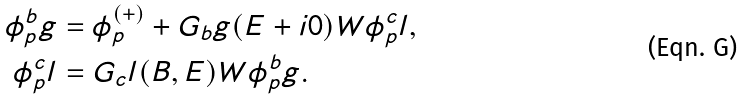<formula> <loc_0><loc_0><loc_500><loc_500>\phi _ { p } ^ { b } g & = \phi _ { p } ^ { ( + ) } + G _ { b } g ( E + i 0 ) W \phi _ { p } ^ { c } l , \\ \phi _ { p } ^ { c } l & = G _ { c } l ( B , E ) W \phi _ { p } ^ { b } g .</formula> 